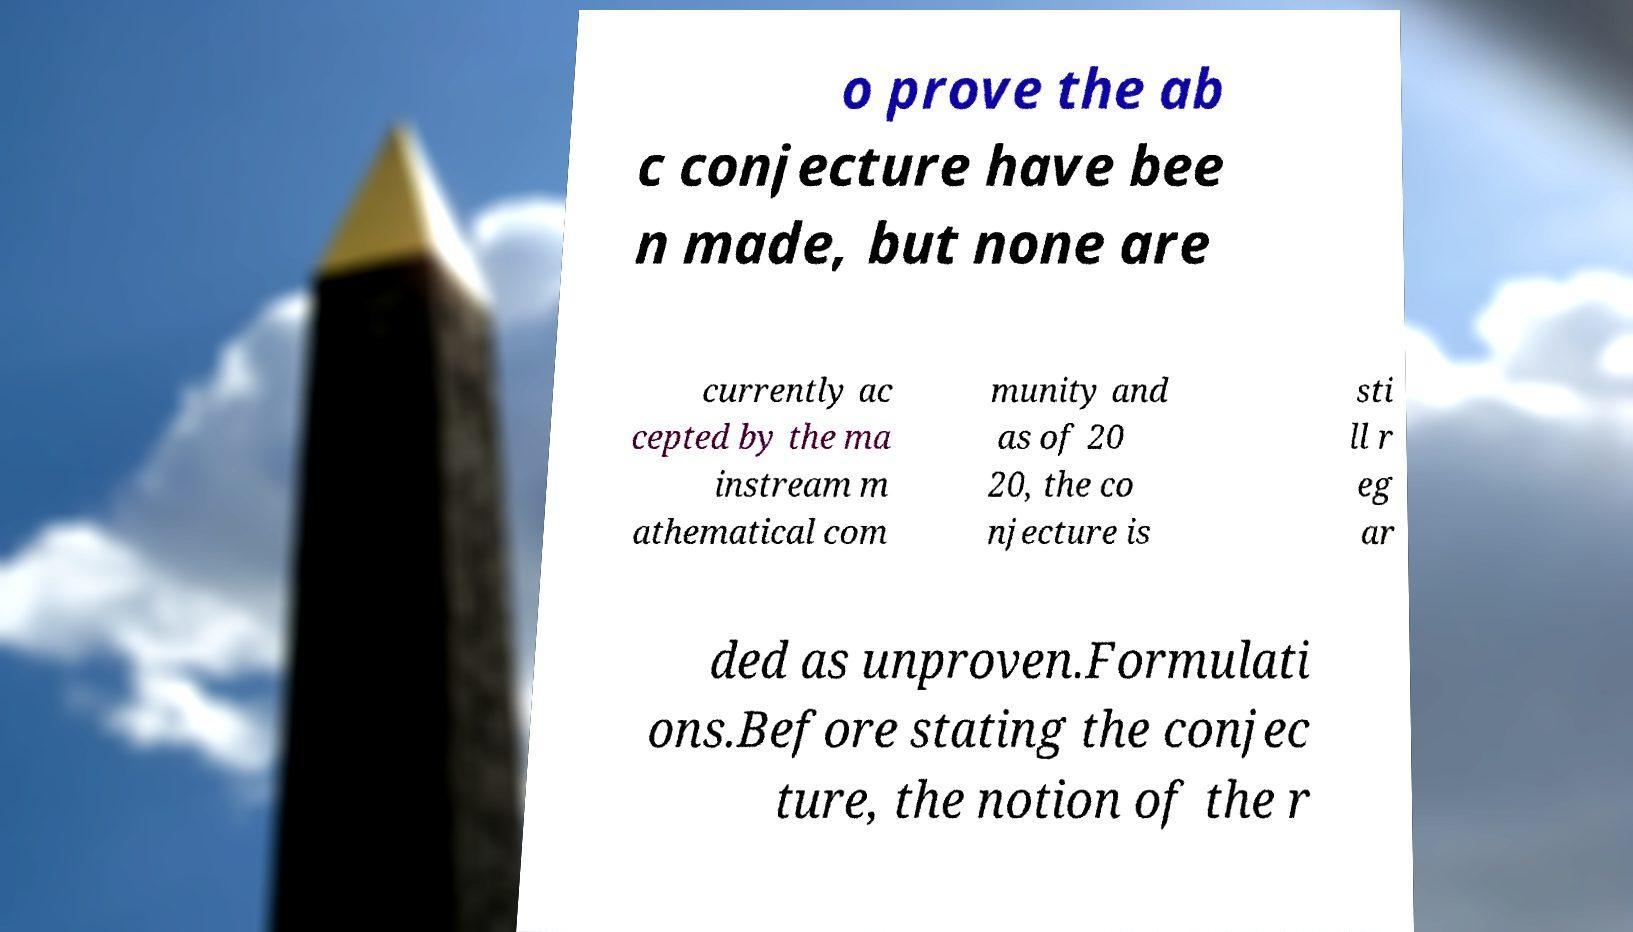There's text embedded in this image that I need extracted. Can you transcribe it verbatim? o prove the ab c conjecture have bee n made, but none are currently ac cepted by the ma instream m athematical com munity and as of 20 20, the co njecture is sti ll r eg ar ded as unproven.Formulati ons.Before stating the conjec ture, the notion of the r 